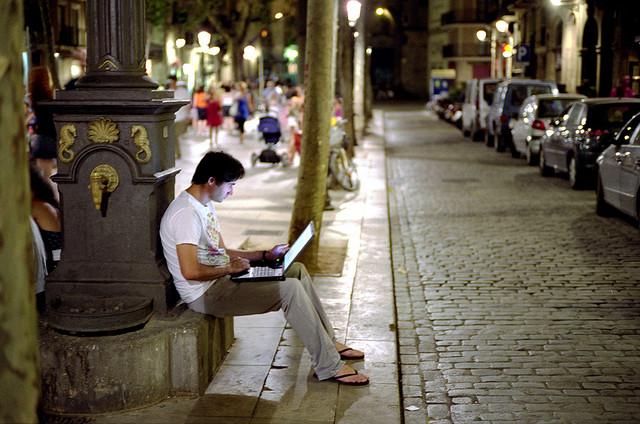Is that a train parked on the right side of the photo?
Keep it brief. No. Is it at night?
Be succinct. Yes. Is the man's laptop plugged in?
Answer briefly. No. 